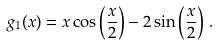Convert formula to latex. <formula><loc_0><loc_0><loc_500><loc_500>g _ { 1 } ( x ) = x \cos \left ( \frac { x } { 2 } \right ) - 2 \sin \left ( \frac { x } { 2 } \right ) \, .</formula> 